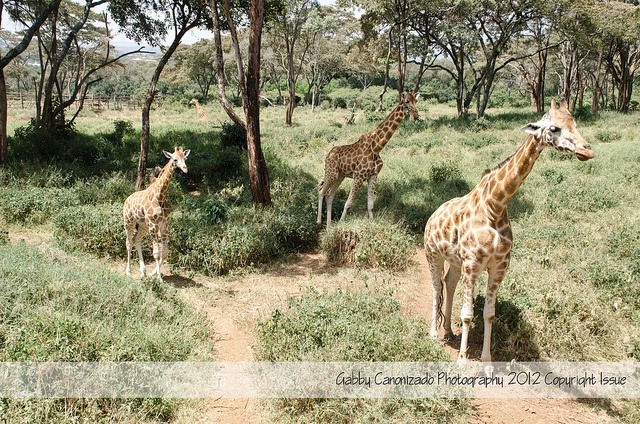Describe the objects in this image and their specific colors. I can see giraffe in black, ivory, tan, and gray tones, giraffe in black, maroon, gray, tan, and darkgray tones, giraffe in black, ivory, tan, and darkgray tones, and giraffe in black, tan, and beige tones in this image. 